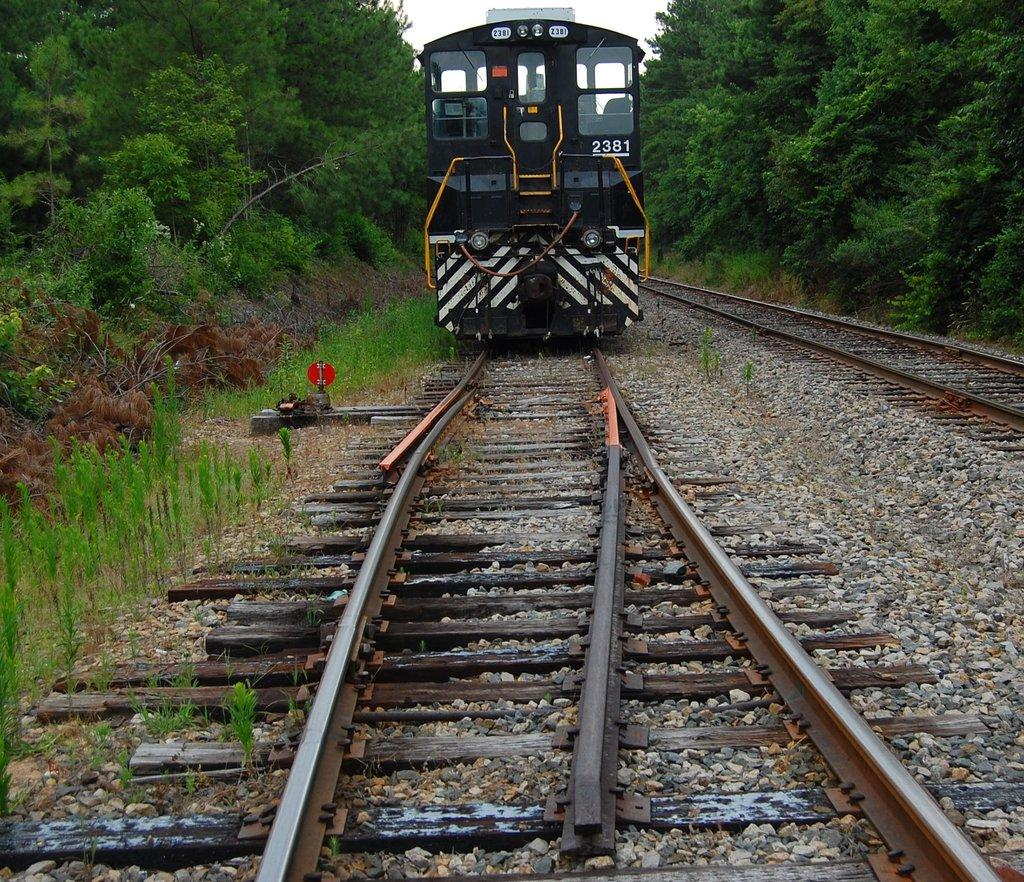What is the main subject of the image? The main subject of the image is a train. Can you describe the train's position in the image? The train is on a track. What type of terrain can be seen in the image? The ground, stones, plants, grass, and trees are visible in the image. What part of the natural environment is visible in the image? The sky is visible in the image. What type of songs can be heard coming from the train in the image? There is no indication in the image that any songs are being played or heard, so it's not possible to determine what songs might be heard. 